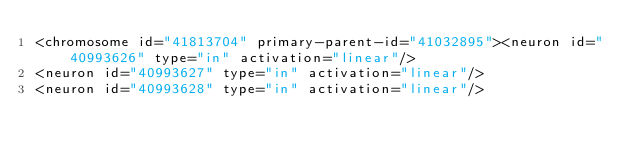Convert code to text. <code><loc_0><loc_0><loc_500><loc_500><_XML_><chromosome id="41813704" primary-parent-id="41032895"><neuron id="40993626" type="in" activation="linear"/>
<neuron id="40993627" type="in" activation="linear"/>
<neuron id="40993628" type="in" activation="linear"/></code> 